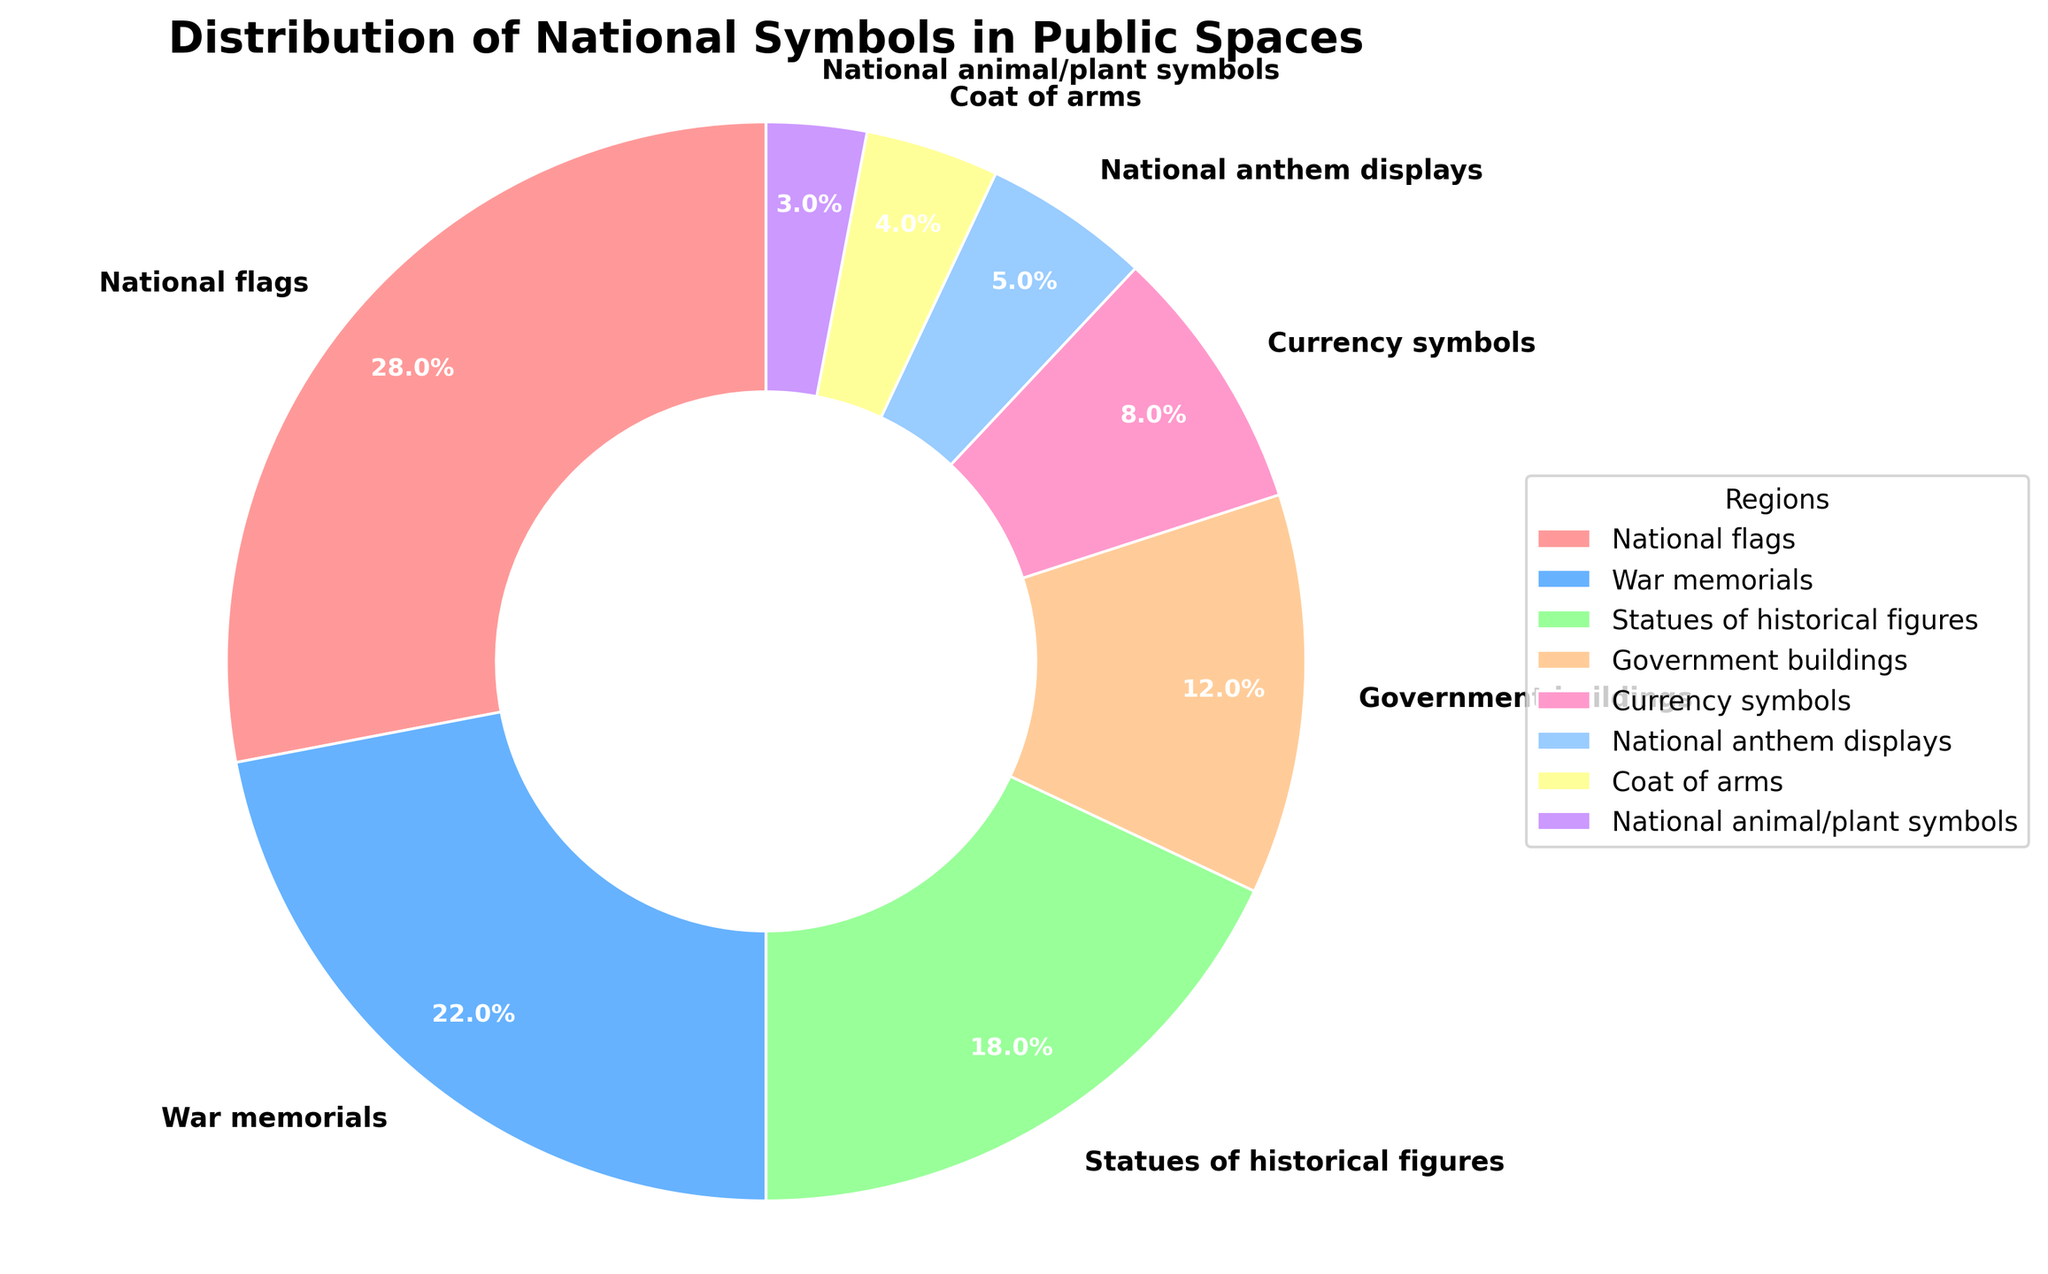Which national symbol is the most prevalent in public spaces? The sizes in the pie chart indicate the distribution percentages, and the largest wedge represents the most prevalent symbol. National flags occupy 28%, the largest share.
Answer: National flags What percentage of national symbols in public spaces are related to historical figures and war memorials combined? To find the combined percentage, add the percentages of statues of historical figures and war memorials. Statues: 18%, War memorials: 22%. Total = 18% + 22% = 40%.
Answer: 40% Which symbol is less common, currency symbols or national anthem displays? Compare the wedges representing currency symbols and national anthem displays. Currency symbols occupy 8%, while national anthem displays occupy 5%. National anthem displays are less common.
Answer: National anthem displays What visual attribute indicates the national animals/plants in the pie chart? Identify the specific wedge associated with national animals/plants by its percentage. It is the smallest wedge, colored in a deep purple shade and represents 3% of the total.
Answer: Deep purple shade, 3% Out of government buildings and national anthem displays, which one is more frequent and by how much? Government buildings have a higher percentage than national anthem displays. Government buildings: 12%, National anthem displays: 5%. Difference = 12% - 5% = 7%.
Answer: Government buildings by 7% Rank the symbols from most to least common based on their percentages. Arrange the symbols according to their sizes from the largest to the smallest: National flags (28%), War memorials (22%), Statues of historical figures (18%), Government buildings (12%), Currency symbols (8%), National anthem displays (5%), Coat of arms (4%), National animals/plants (3%).
Answer: National flags > War memorials > Statues of historical figures > Government buildings > Currency symbols > National anthem displays > Coat of arms > National animals/plants What's the combined percentage of national symbols that represent the country's national anthem, coat of arms, and national plants/animals? Sum the percentages for national anthem displays, coat of arms, and national plants/animals. National anthem displays: 5%, Coat of arms: 4%, National plants/animals: 3%. Total = 5% + 4% + 3% = 12%.
Answer: 12% Which is more common, statues of historical figures or government buildings, and by what percentage difference? Statues of historical figures occupy 18%, while government buildings occupy 12%. Difference = 18% - 12% = 6%. Statues of historical figures are more common by 6%.
Answer: Statues of historical figures by 6% What proportion of the total pie chart is not occupied by national flags? National flags make up 28% of the pie chart. The remaining proportion is 100% - 28% = 72%.
Answer: 72% Is the proportion of war memorials greater than the combined proportion of national animals/plants and coat of arms? War memorials make up 22%. National animals/plants: 3%, Coat of arms: 4%. Combined = 3% + 4% = 7%. Compare 22% and 7%. War memorials are greater.
Answer: Yes 